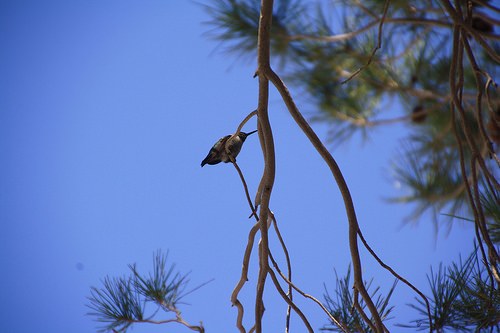<image>
Is there a bird on the tree? Yes. Looking at the image, I can see the bird is positioned on top of the tree, with the tree providing support. Is the bird in the sky? Yes. The bird is contained within or inside the sky, showing a containment relationship. 